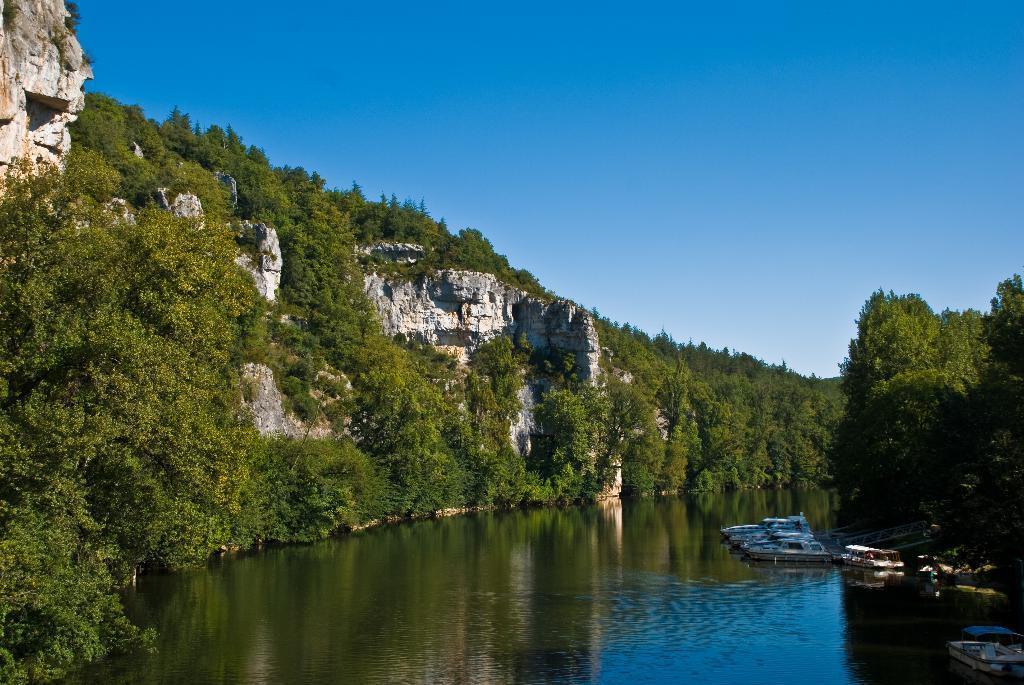How would you summarize this image in a sentence or two? In this image we can see a few boats on the water, there are some trees and mountains, in the background, we can see the sky. 